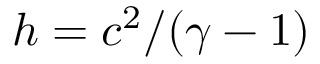Convert formula to latex. <formula><loc_0><loc_0><loc_500><loc_500>h = c ^ { 2 } / ( \gamma - 1 )</formula> 